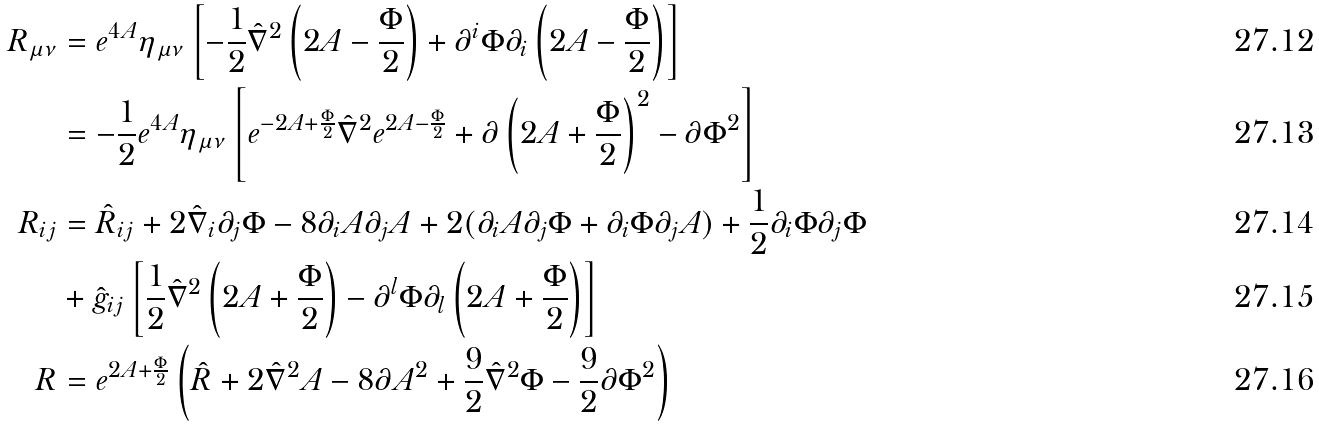Convert formula to latex. <formula><loc_0><loc_0><loc_500><loc_500>R _ { \mu \nu } & = e ^ { 4 A } \eta _ { \mu \nu } \left [ - \frac { 1 } { 2 } \hat { \nabla } ^ { 2 } \left ( 2 A - \frac { \Phi } { 2 } \right ) + \partial ^ { i } \Phi \partial _ { i } \left ( 2 A - \frac { \Phi } { 2 } \right ) \right ] \\ & = - \frac { 1 } { 2 } e ^ { 4 A } \eta _ { \mu \nu } \left [ e ^ { - 2 A + \frac { \Phi } { 2 } } \hat { \nabla } ^ { 2 } e ^ { 2 A - \frac { \Phi } { 2 } } + \partial \left ( 2 A + \frac { \Phi } { 2 } \right ) ^ { 2 } - \partial \Phi ^ { 2 } \right ] \\ R _ { i j } & = \hat { R } _ { i j } + 2 \hat { \nabla } _ { i } \partial _ { j } \Phi - 8 \partial _ { i } A \partial _ { j } A + 2 ( \partial _ { i } A \partial _ { j } \Phi + \partial _ { i } \Phi \partial _ { j } A ) + \frac { 1 } { 2 } \partial _ { i } \Phi \partial _ { j } \Phi \\ & + \hat { g } _ { i j } \left [ \frac { 1 } { 2 } \hat { \nabla } ^ { 2 } \left ( 2 A + \frac { \Phi } { 2 } \right ) - \partial ^ { l } \Phi \partial _ { l } \left ( 2 A + \frac { \Phi } { 2 } \right ) \right ] \\ R & = e ^ { 2 A + \frac { \Phi } { 2 } } \left ( \hat { R } + 2 \hat { \nabla } ^ { 2 } A - 8 \partial A ^ { 2 } + \frac { 9 } { 2 } \hat { \nabla } ^ { 2 } \Phi - \frac { 9 } { 2 } \partial \Phi ^ { 2 } \right )</formula> 